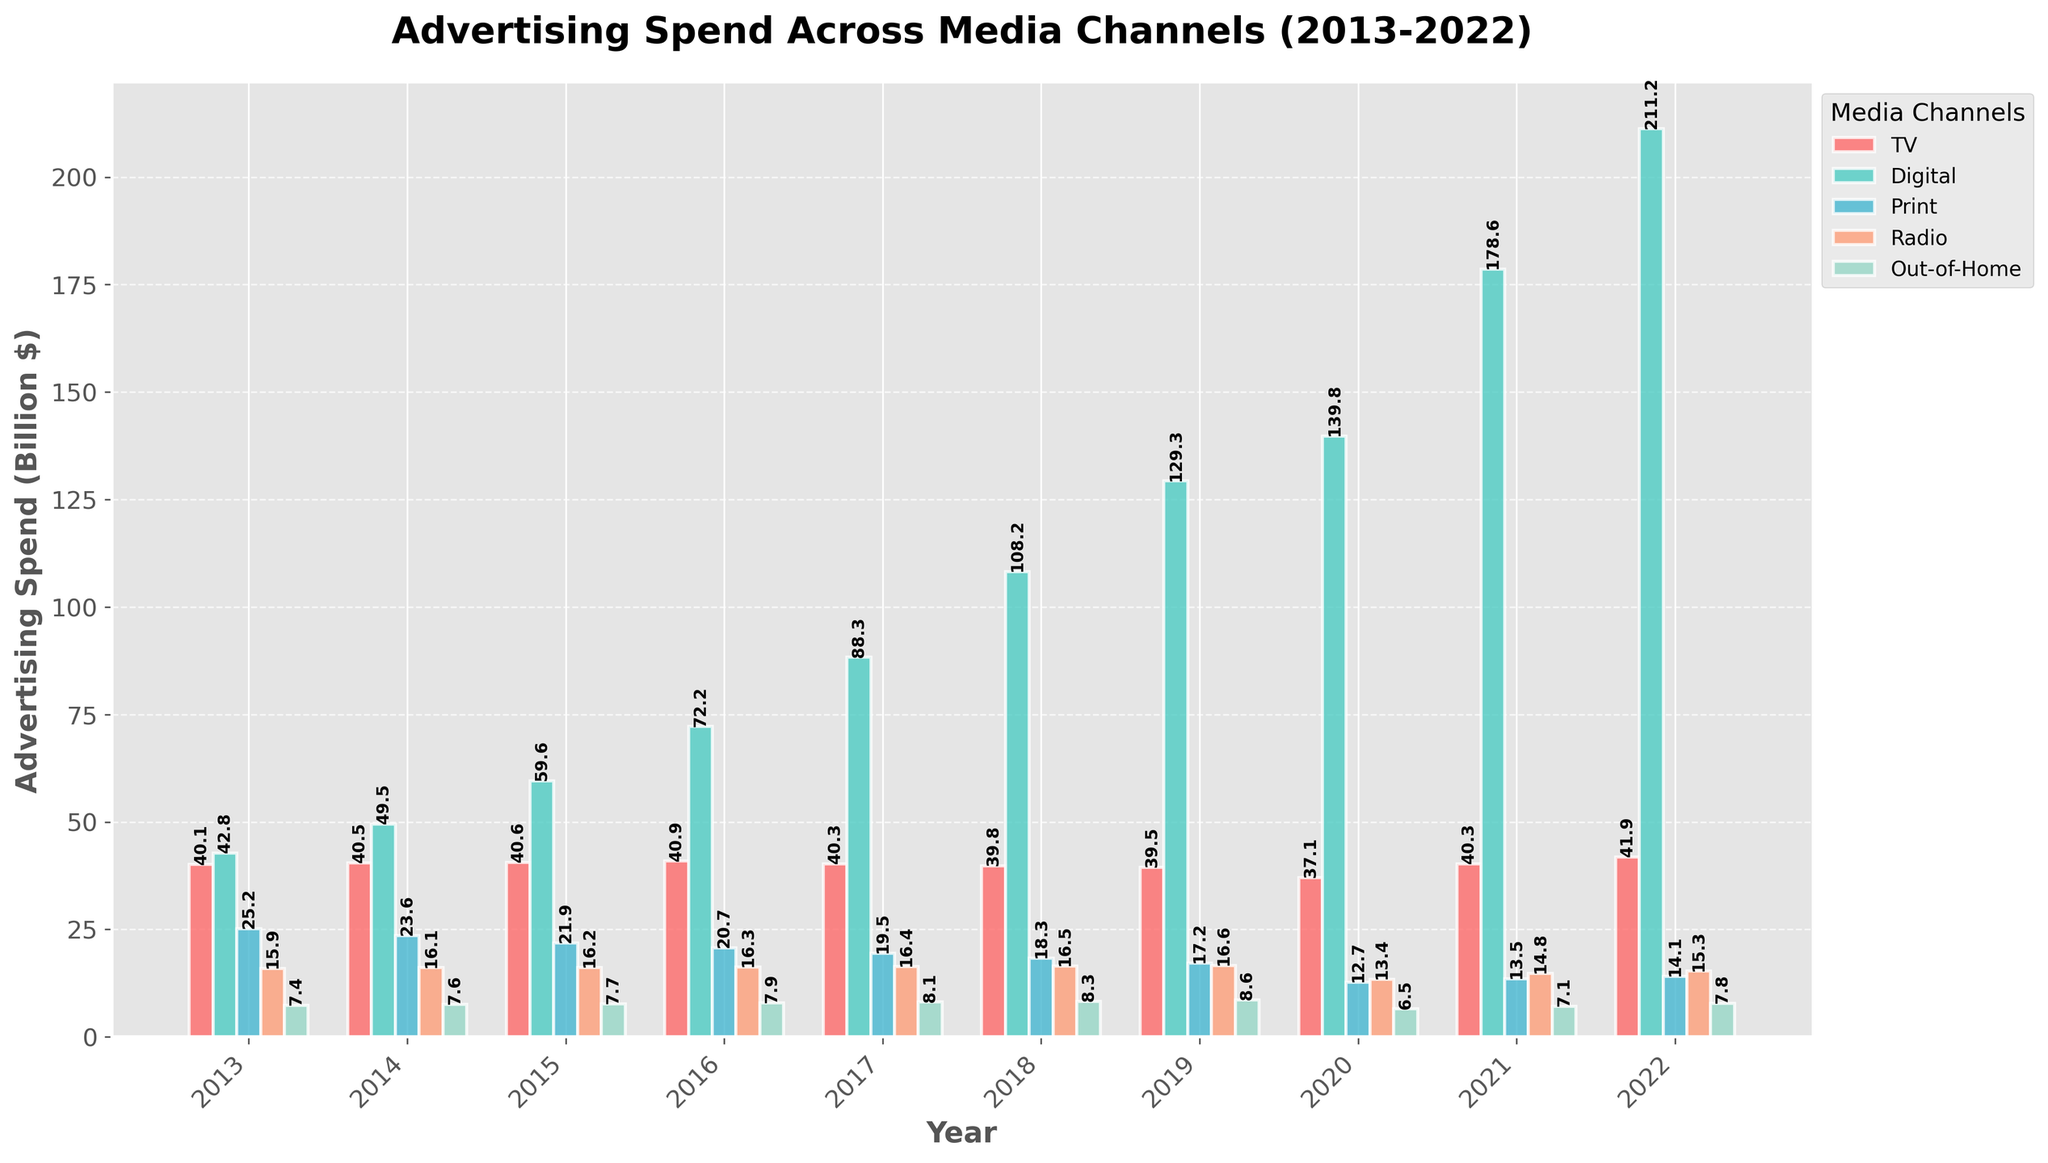Which media channel had the highest advertising spend in 2022? Observe the heights of the bars for 2022. The tallest bar corresponds to Digital.
Answer: Digital By how much did the Digital advertising spend increase from 2013 to 2022? Subtract the Digital spend in 2013 (42.8) from the Digital spend in 2022 (211.2). Calculation: 211.2 - 42.8 = 168.4 billion dollars
Answer: 168.4 billion dollars Which two media channels had almost equal advertising spend in 2020? Compare the bar heights for 2020. TV and Digital are the closest in value, both being around 139.8 billion dollars and 137.1 billion dollars, respectively.
Answer: TV and Digital What is the overall trend for Print advertising spend from 2013 to 2022? Look at the progression of the Print bars from left to right, which show a decreasing trend over the years.
Answer: Decreasing By how much did the total advertising spend across all channels change from 2019 to 2020? Sum the spend for all channels in 2019 and in 2020 and find the difference. For 2019: 39.5 + 129.3 + 17.2 + 16.6 + 8.6 = 211.2. For 2020: 37.1 + 139.8 + 12.7 + 13.4 + 6.5 = 209.5. Calculation: 209.5 - 211.2 = -1.7 billion dollars
Answer: 1.7 billion dollars decrease Which year had the highest total advertising spend combined across all media channels? Add up the heights of the bars for each year and identify the year with the largest sum. The sums are 131.4, 137.3, 146.0, 158.0, 172.6, 191.1, 211.2, 209.5, 254.3, and 290.3 for 2013 to 2022, respectively. The highest sum is in 2022.
Answer: 2022 How did the Radio advertising spend change from 2019 to 2020? Subtract the Radio spend in 2020 (13.4) from the spend in 2019 (16.6). Calculation: 16.6 - 13.4 = 3.2 billion dollars decrease
Answer: 3.2 billion dollars decrease In which year did Out-of-Home advertising spend see its biggest increase compared to the previous year? Identify the year with the largest difference in Out-of-Home spend compared to the previous year. The biggest increase is from 2019 (8.6) to 2020 (6.5), which is a decrease. Thus, the correct answer is actually the largest non-negative increment, which is from 2016 (7.9) to 2017 (8.1), an increase of 0.2.
Answer: 2017 Which media channel had the smallest change in advertising spend from 2013 to 2022? Compare the differences in each channel's spend between 2013 and 2022. TV changed from 40.1 to 41.9, which is a small change of 1.8 billion dollars. The smallest change among all channels.
Answer: TV 